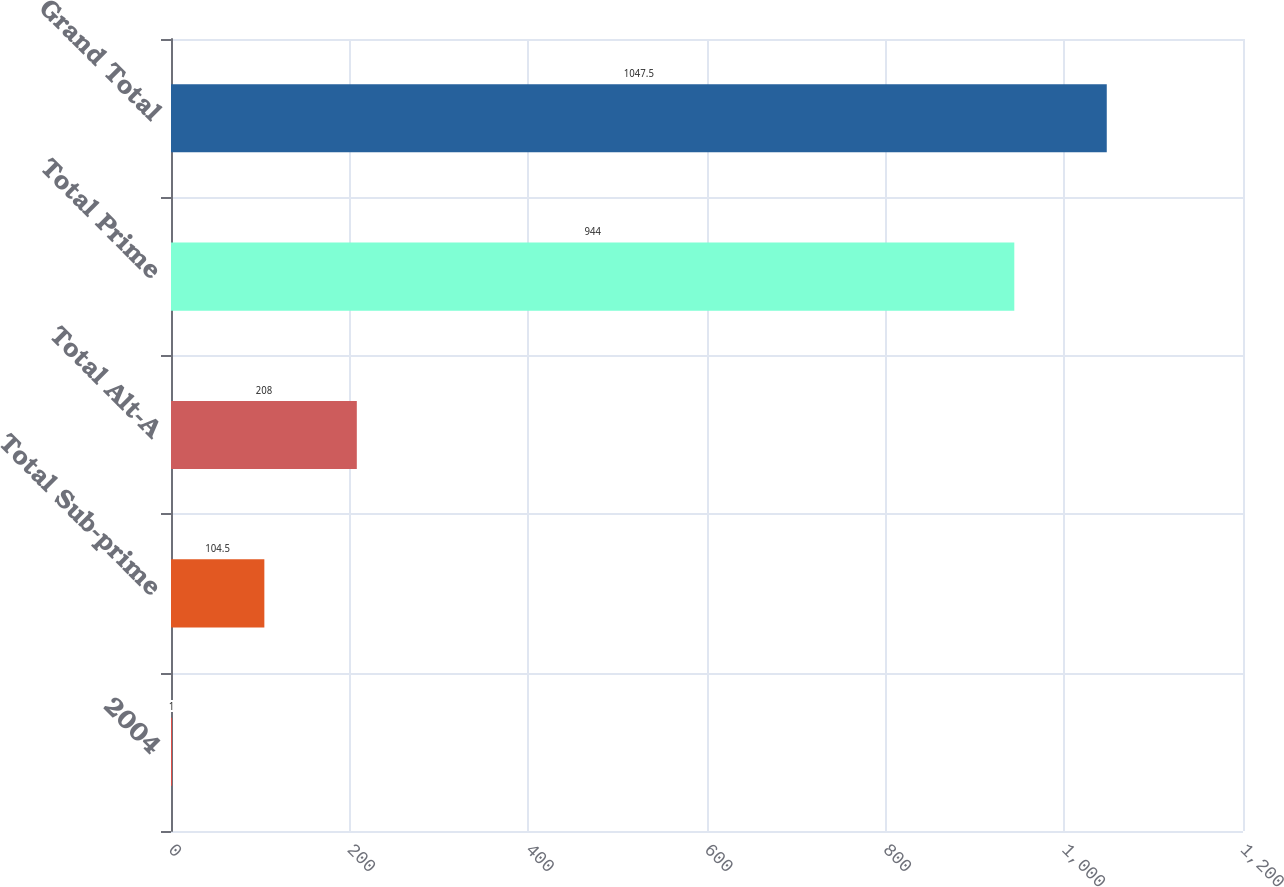<chart> <loc_0><loc_0><loc_500><loc_500><bar_chart><fcel>2004<fcel>Total Sub-prime<fcel>Total Alt-A<fcel>Total Prime<fcel>Grand Total<nl><fcel>1<fcel>104.5<fcel>208<fcel>944<fcel>1047.5<nl></chart> 